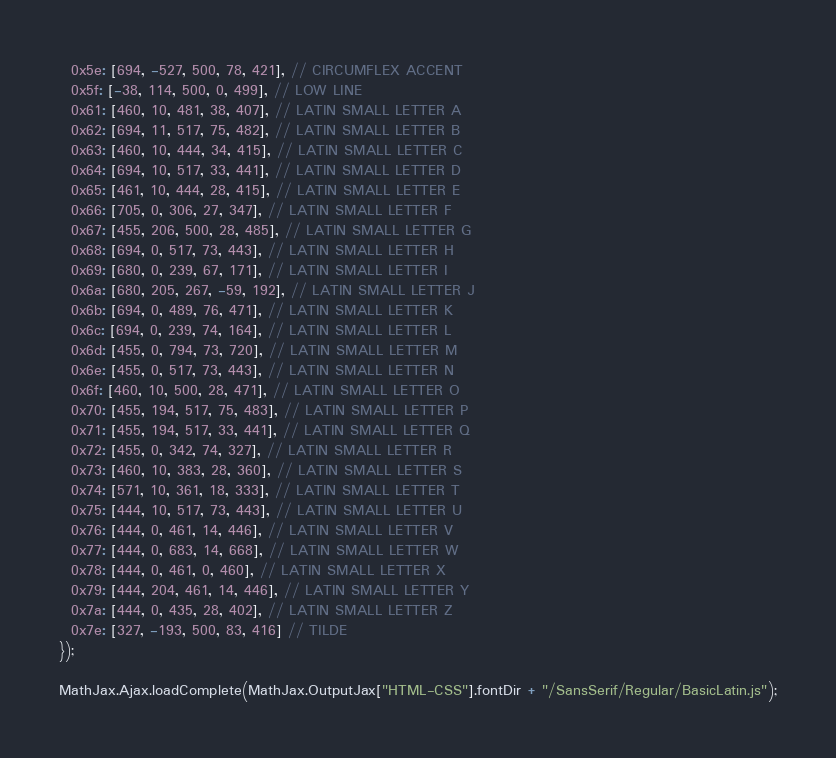Convert code to text. <code><loc_0><loc_0><loc_500><loc_500><_JavaScript_>  0x5e: [694, -527, 500, 78, 421], // CIRCUMFLEX ACCENT
  0x5f: [-38, 114, 500, 0, 499], // LOW LINE
  0x61: [460, 10, 481, 38, 407], // LATIN SMALL LETTER A
  0x62: [694, 11, 517, 75, 482], // LATIN SMALL LETTER B
  0x63: [460, 10, 444, 34, 415], // LATIN SMALL LETTER C
  0x64: [694, 10, 517, 33, 441], // LATIN SMALL LETTER D
  0x65: [461, 10, 444, 28, 415], // LATIN SMALL LETTER E
  0x66: [705, 0, 306, 27, 347], // LATIN SMALL LETTER F
  0x67: [455, 206, 500, 28, 485], // LATIN SMALL LETTER G
  0x68: [694, 0, 517, 73, 443], // LATIN SMALL LETTER H
  0x69: [680, 0, 239, 67, 171], // LATIN SMALL LETTER I
  0x6a: [680, 205, 267, -59, 192], // LATIN SMALL LETTER J
  0x6b: [694, 0, 489, 76, 471], // LATIN SMALL LETTER K
  0x6c: [694, 0, 239, 74, 164], // LATIN SMALL LETTER L
  0x6d: [455, 0, 794, 73, 720], // LATIN SMALL LETTER M
  0x6e: [455, 0, 517, 73, 443], // LATIN SMALL LETTER N
  0x6f: [460, 10, 500, 28, 471], // LATIN SMALL LETTER O
  0x70: [455, 194, 517, 75, 483], // LATIN SMALL LETTER P
  0x71: [455, 194, 517, 33, 441], // LATIN SMALL LETTER Q
  0x72: [455, 0, 342, 74, 327], // LATIN SMALL LETTER R
  0x73: [460, 10, 383, 28, 360], // LATIN SMALL LETTER S
  0x74: [571, 10, 361, 18, 333], // LATIN SMALL LETTER T
  0x75: [444, 10, 517, 73, 443], // LATIN SMALL LETTER U
  0x76: [444, 0, 461, 14, 446], // LATIN SMALL LETTER V
  0x77: [444, 0, 683, 14, 668], // LATIN SMALL LETTER W
  0x78: [444, 0, 461, 0, 460], // LATIN SMALL LETTER X
  0x79: [444, 204, 461, 14, 446], // LATIN SMALL LETTER Y
  0x7a: [444, 0, 435, 28, 402], // LATIN SMALL LETTER Z
  0x7e: [327, -193, 500, 83, 416] // TILDE
});

MathJax.Ajax.loadComplete(MathJax.OutputJax["HTML-CSS"].fontDir + "/SansSerif/Regular/BasicLatin.js");
</code> 